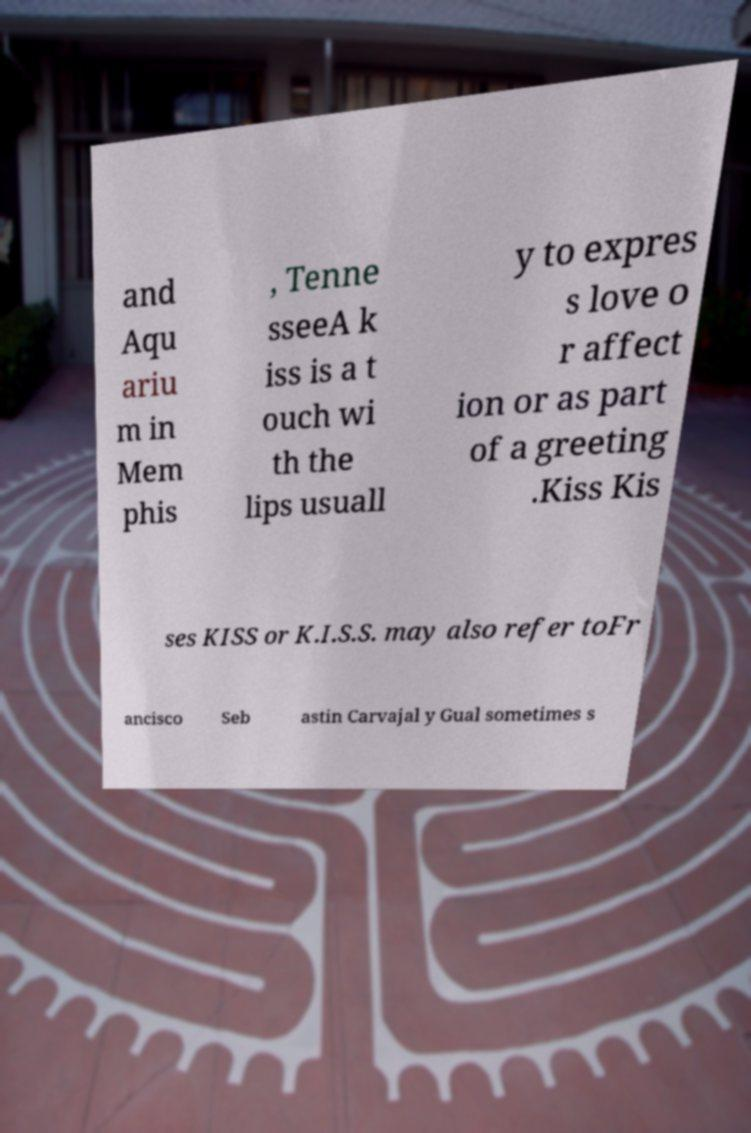What messages or text are displayed in this image? I need them in a readable, typed format. and Aqu ariu m in Mem phis , Tenne sseeA k iss is a t ouch wi th the lips usuall y to expres s love o r affect ion or as part of a greeting .Kiss Kis ses KISS or K.I.S.S. may also refer toFr ancisco Seb astin Carvajal y Gual sometimes s 